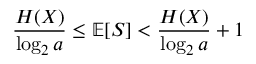<formula> <loc_0><loc_0><loc_500><loc_500>{ \frac { H ( X ) } { \log _ { 2 } a } } \leq \mathbb { E } [ S ] < { \frac { H ( X ) } { \log _ { 2 } a } } + 1</formula> 